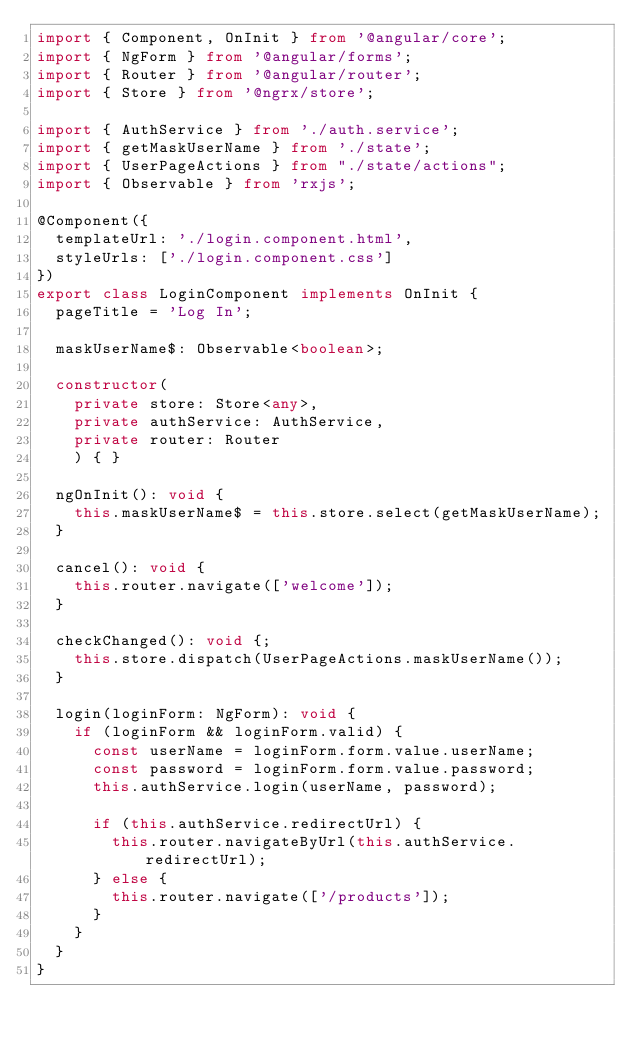<code> <loc_0><loc_0><loc_500><loc_500><_TypeScript_>import { Component, OnInit } from '@angular/core';
import { NgForm } from '@angular/forms';
import { Router } from '@angular/router';
import { Store } from '@ngrx/store';

import { AuthService } from './auth.service';
import { getMaskUserName } from './state';
import { UserPageActions } from "./state/actions";
import { Observable } from 'rxjs';

@Component({
  templateUrl: './login.component.html',
  styleUrls: ['./login.component.css']
})
export class LoginComponent implements OnInit {
  pageTitle = 'Log In';

  maskUserName$: Observable<boolean>;

  constructor(
    private store: Store<any>,
    private authService: AuthService,
    private router: Router
    ) { }

  ngOnInit(): void {
    this.maskUserName$ = this.store.select(getMaskUserName);
  }

  cancel(): void {
    this.router.navigate(['welcome']);
  }

  checkChanged(): void {;
    this.store.dispatch(UserPageActions.maskUserName());
  }

  login(loginForm: NgForm): void {
    if (loginForm && loginForm.valid) {
      const userName = loginForm.form.value.userName;
      const password = loginForm.form.value.password;
      this.authService.login(userName, password);

      if (this.authService.redirectUrl) {
        this.router.navigateByUrl(this.authService.redirectUrl);
      } else {
        this.router.navigate(['/products']);
      }
    }
  }
}
</code> 